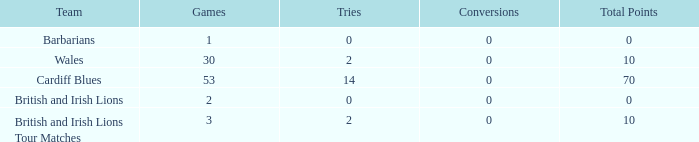What is the average number of conversions for the Cardiff Blues with less than 14 tries? None. 